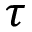Convert formula to latex. <formula><loc_0><loc_0><loc_500><loc_500>\tau</formula> 